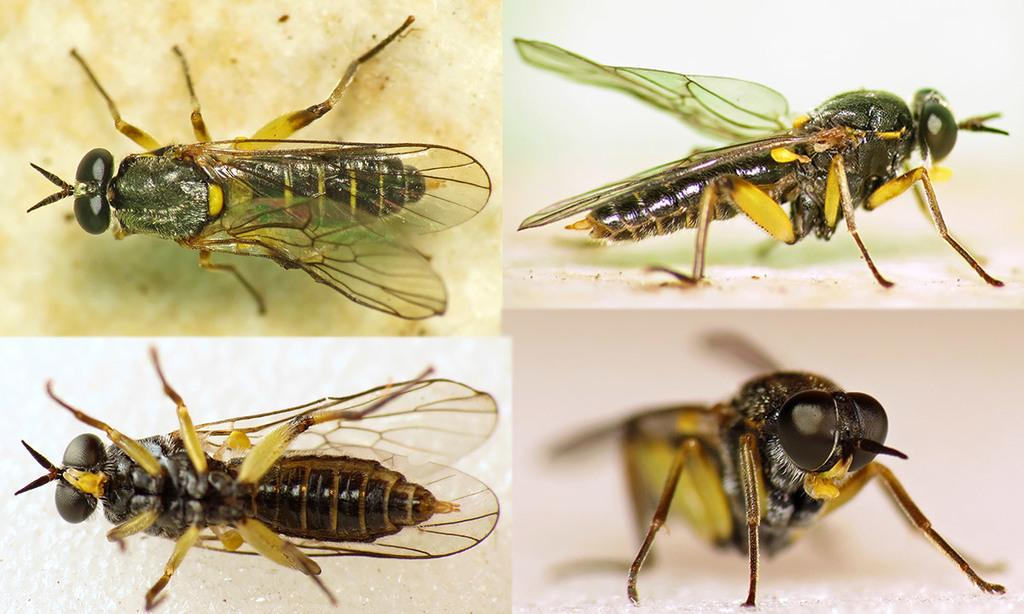What type of artwork is the image? The image is a collage. How many insects can be seen in the collage? There are four insects in the image. What type of bread is featured in the story depicted in the image? There is no story or bread present in the image; it is a collage of insects. 